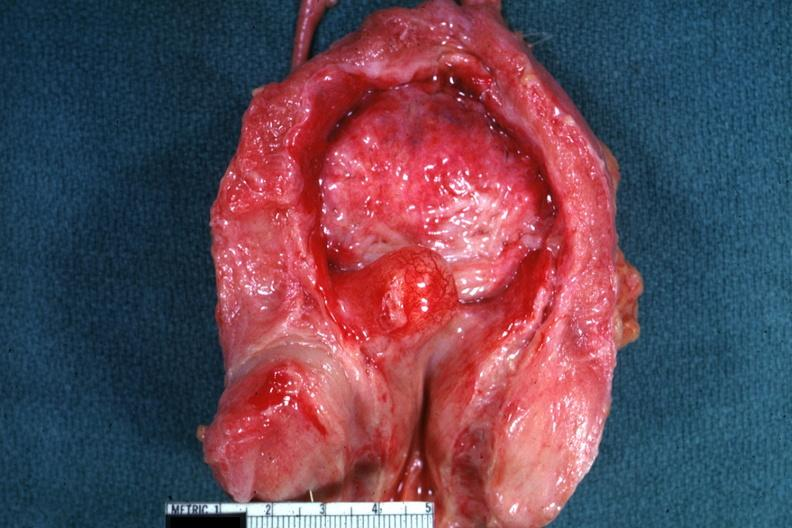s prostate present?
Answer the question using a single word or phrase. Yes 